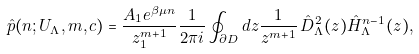Convert formula to latex. <formula><loc_0><loc_0><loc_500><loc_500>\hat { p } ( n ; U _ { \Lambda } , m , { c } ) = \frac { A _ { 1 } e ^ { \beta \mu n } } { z _ { 1 } ^ { m + 1 } } \frac { 1 } { 2 \pi i } \oint _ { \partial D } d z \frac { 1 } { z ^ { m + 1 } } \, \hat { D } _ { \Lambda } ^ { 2 } ( z ) \hat { H } _ { \Lambda } ^ { n - 1 } ( z ) ,</formula> 